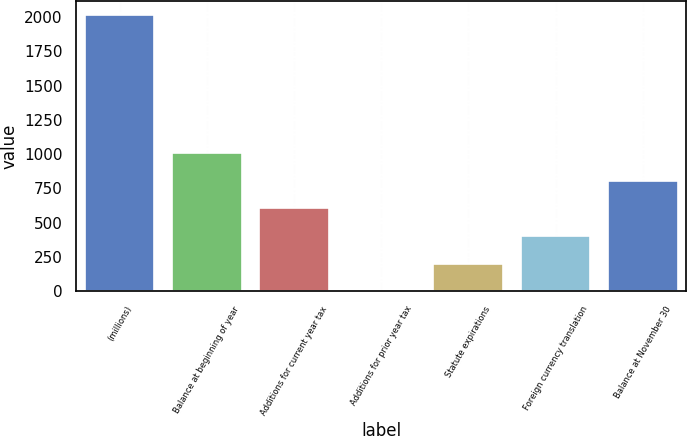<chart> <loc_0><loc_0><loc_500><loc_500><bar_chart><fcel>(millions)<fcel>Balance at beginning of year<fcel>Additions for current year tax<fcel>Additions for prior year tax<fcel>Statute expirations<fcel>Foreign currency translation<fcel>Balance at November 30<nl><fcel>2014<fcel>1007.35<fcel>604.69<fcel>0.7<fcel>202.03<fcel>403.36<fcel>806.02<nl></chart> 